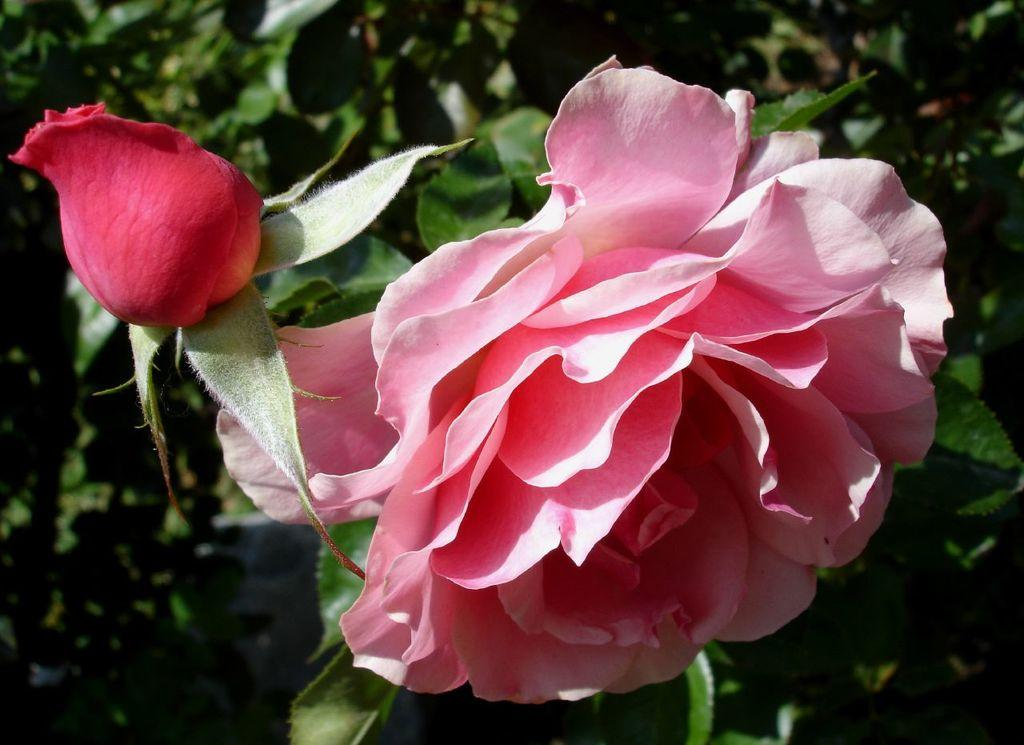What type of living organisms can be seen in the image? There are flowers and plants in the image. Can you describe the plants in the image? The plants in the image are not specified, but they are present alongside the flowers. What type of floor can be seen in the image? There is no floor visible in the image; it only features flowers and plants. Who is the representative of the plants in the image? There is no representative present in the image; it only features flowers and plants. 